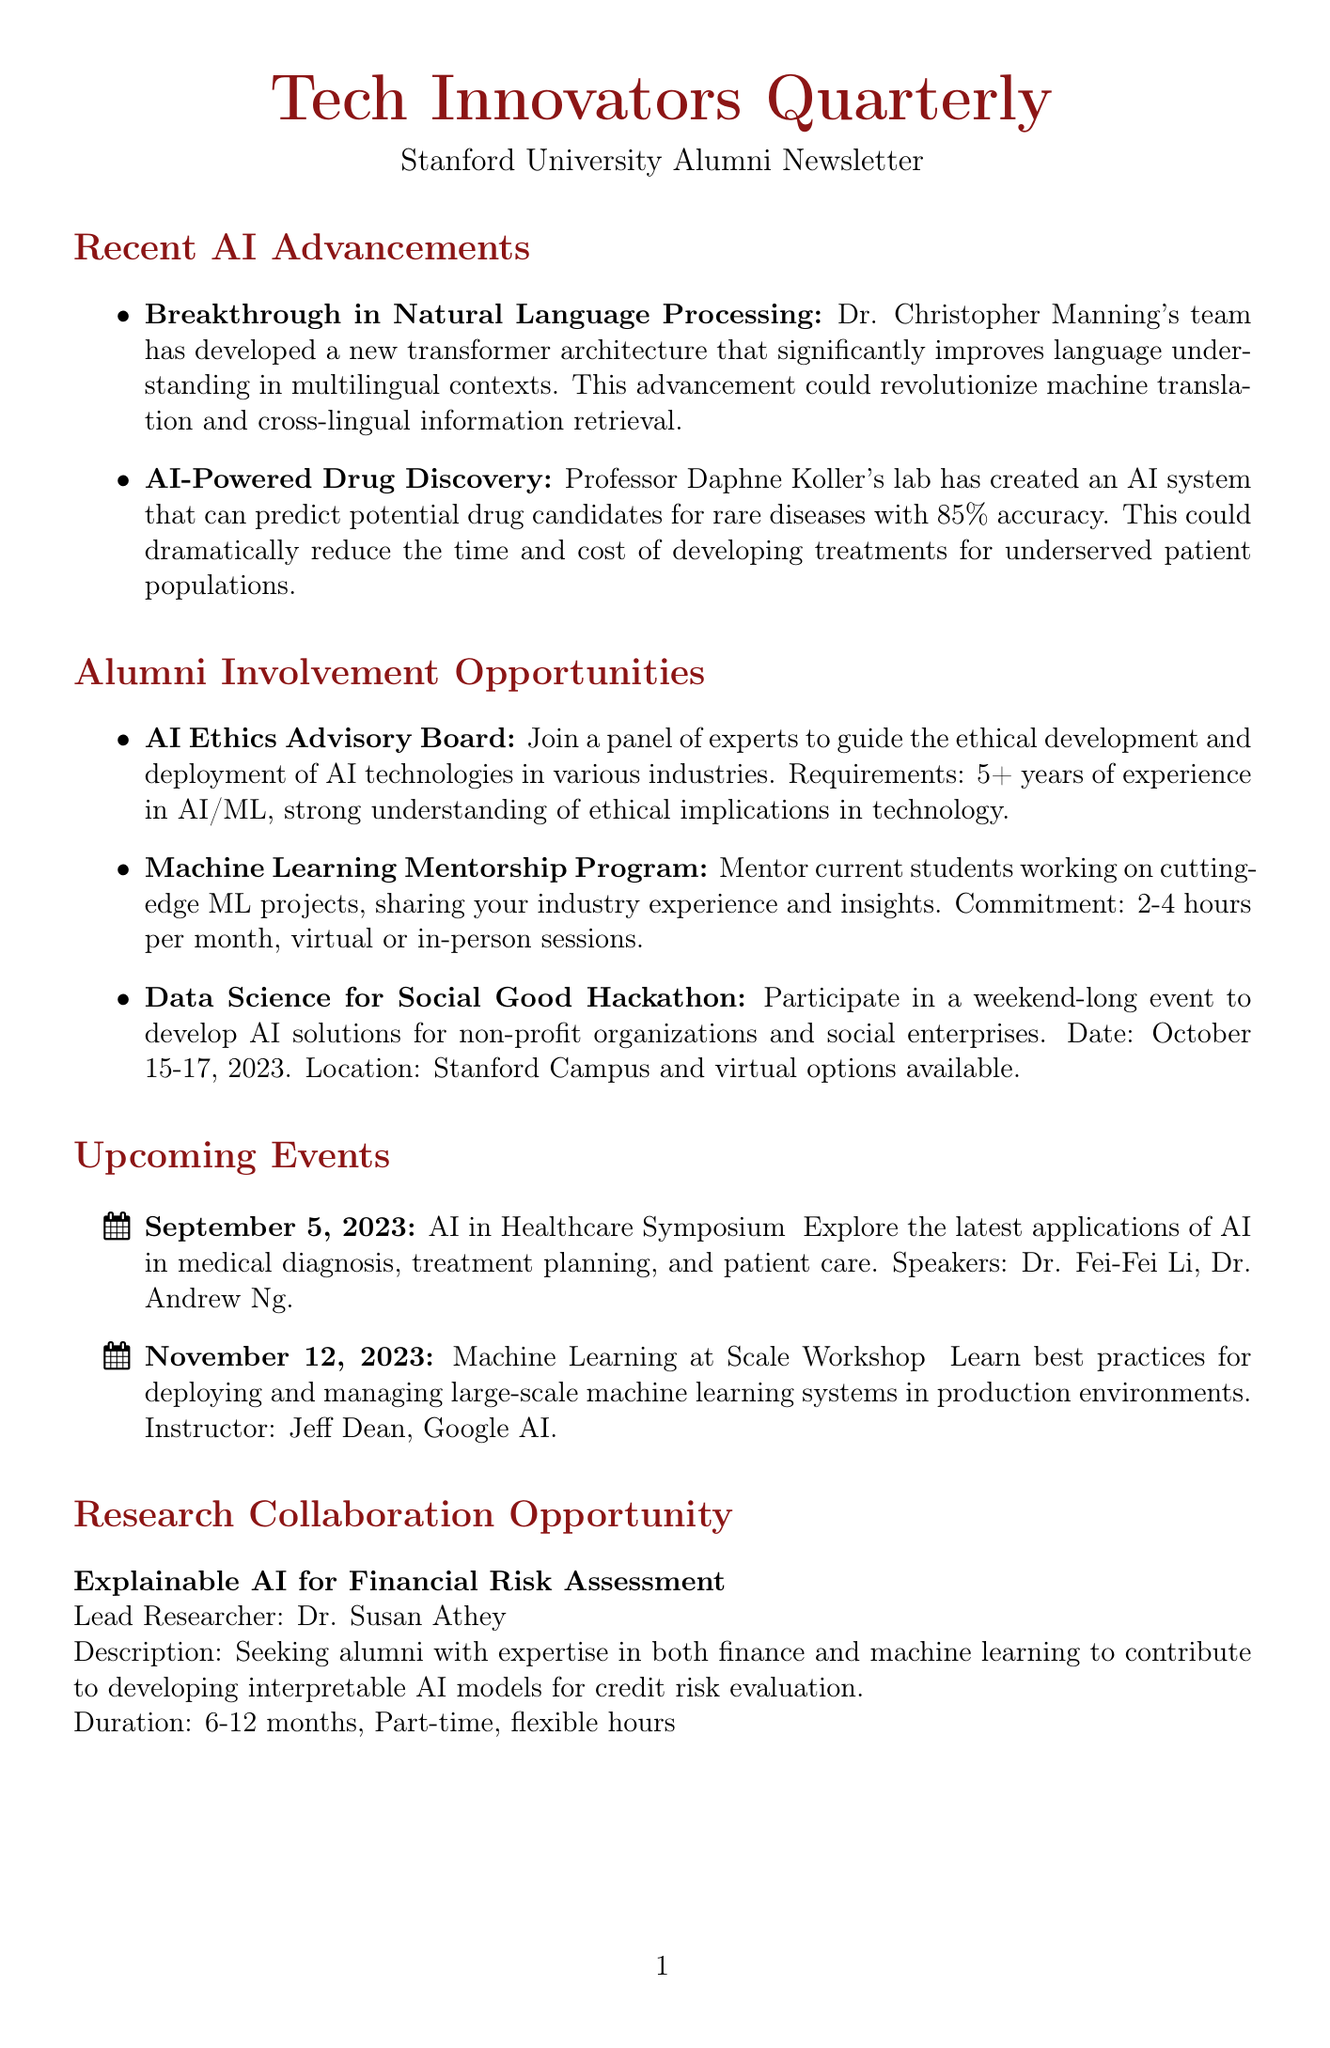What is the name of the newsletter? The name of the newsletter is mentioned at the beginning of the document.
Answer: Tech Innovators Quarterly Who is leading the research collaboration project? The lead researcher for the collaboration opportunity is specifically named in the document.
Answer: Dr. Susan Athey What is the date for the upcoming hackathon? The hackathon date is provided as part of the alumni involvement opportunities section.
Answer: October 15-17, 2023 What achievement is highlighted for Dr. Timnit Gebru? Dr. Timnit Gebru's achievement is specified in the alumni spotlight.
Answer: Recognized as one of Time's 100 Most Influential People How much funding is available through the AI for Climate Action Grant? The funding range is directly stated in the funding opportunities section.
Answer: $50,000 - $250,000 What medical application is discussed in the AI in Healthcare Symposium? The symposium description mentions a specific focus area for AI application.
Answer: Medical diagnosis What is the commitment for the Machine Learning Mentorship Program? The commitment required for mentoring is detailed in the alumni involvement opportunities.
Answer: 2-4 hours per month What is the main impact of the breakthrough in Natural Language Processing? The document describes the potential impact of this advancement.
Answer: Revolutionize machine translation and cross-lingual information retrieval 